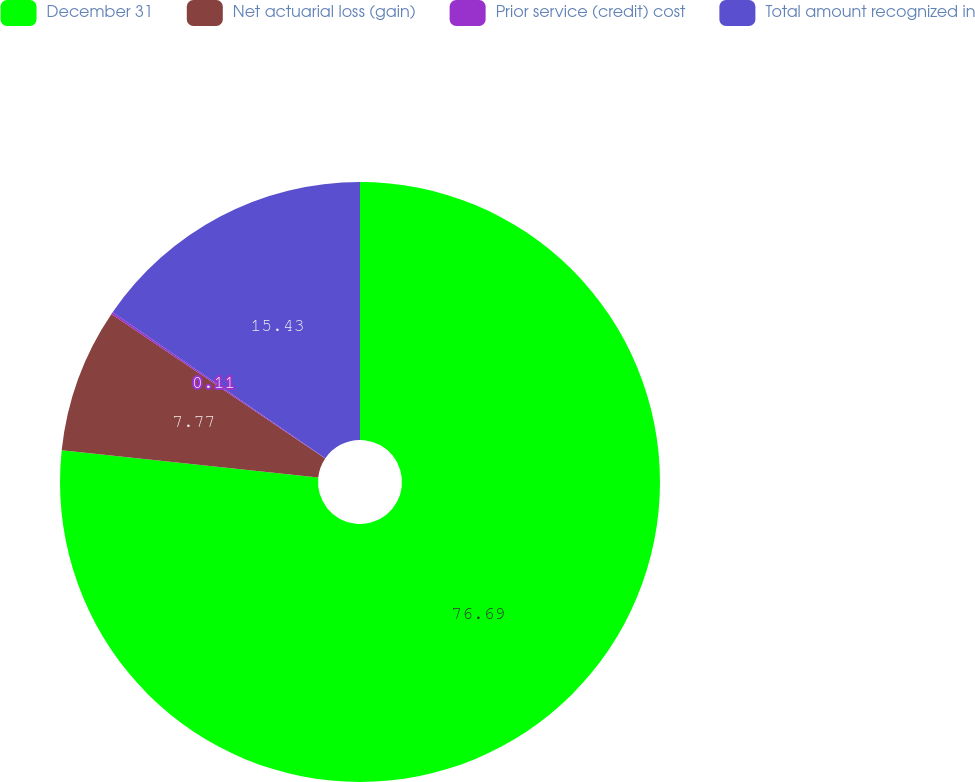Convert chart to OTSL. <chart><loc_0><loc_0><loc_500><loc_500><pie_chart><fcel>December 31<fcel>Net actuarial loss (gain)<fcel>Prior service (credit) cost<fcel>Total amount recognized in<nl><fcel>76.69%<fcel>7.77%<fcel>0.11%<fcel>15.43%<nl></chart> 